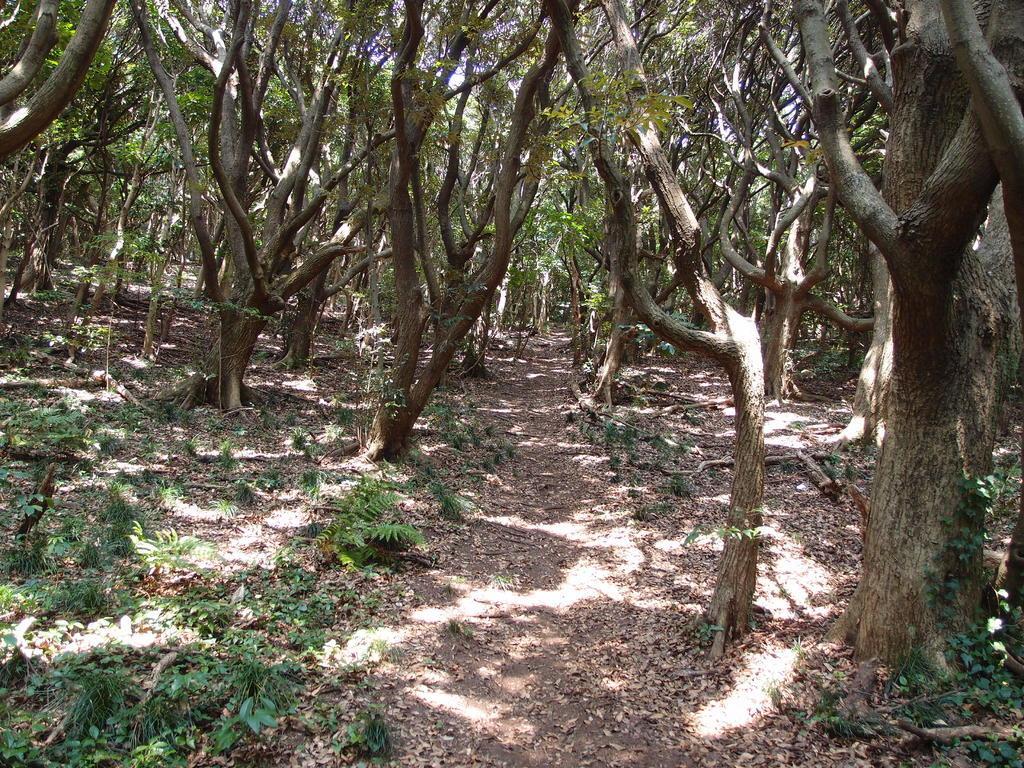Please provide a concise description of this image. This place is looking like a forest. At the bottom of the image I can see the plants on the ground and there are many trees. 